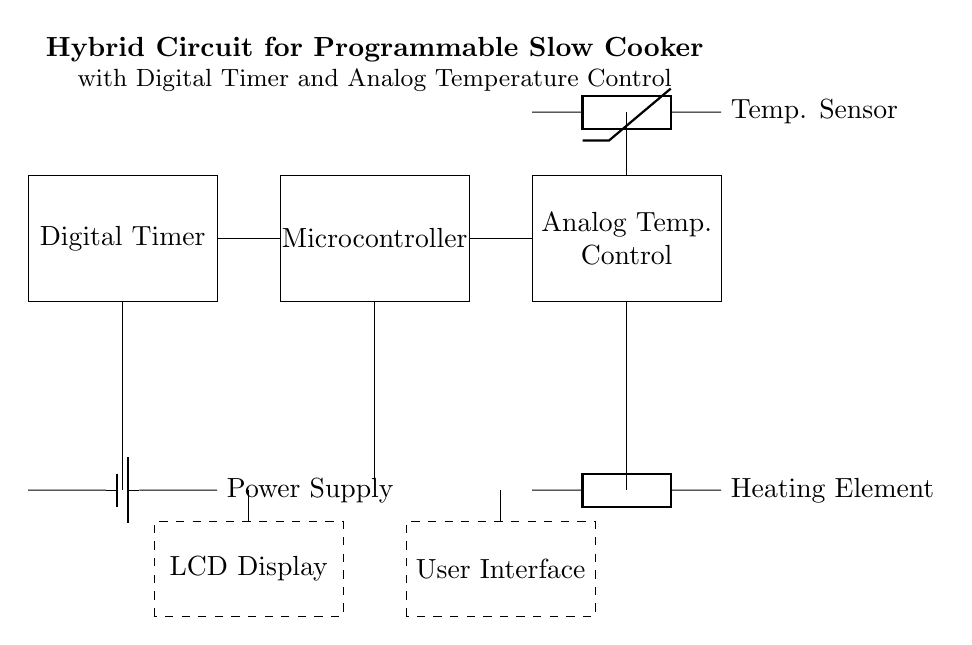What is the function of the component labeled "Microcontroller"? The microcontroller is responsible for processing the digital timer input and controlling the heating element accordingly. It takes signals from the timer and adjusts the heating element's output to maintain the desired cooking temperature and time.
Answer: Processing What type of temperature sensor is used in this circuit? The circuit diagram specifies a thermistor, which is a type of temperature sensor that changes its resistance with temperature fluctuations. This allows it to provide accurate temperature readings for the cooking process.
Answer: Thermistor How many main components are in this hybrid circuit? The schematic indicates four main components: the digital timer, microcontroller, analog temperature control, and heating element. These components work together to regulate the cooking process.
Answer: Four What does the "LCD Display" indicate? The LCD display is used for showing the cooking time and temperature settings, allowing the user to monitor and adjust the slow cooker settings according to their preferences.
Answer: Monitoring Which component connects directly to the analog temperature control? The heating element connects directly to the analog temperature control, allowing it to vary the heating based on the feedback received from the temperature sensor. This ensures the temperature is managed properly during cooking.
Answer: Heating Element What is the purpose of the User Interface in this circuit? The User Interface allows users to set cooking times and temperatures interactively, sending the input to the microcontroller for processing. It serves as the means for users to control the slow cooker settings directly.
Answer: Control Which component provides the power supply for the circuit? The circuit indicates a battery as the power supply, which powers the entire system, including the digital timer, microcontroller, and heating element, ensuring they operate effectively.
Answer: Battery 